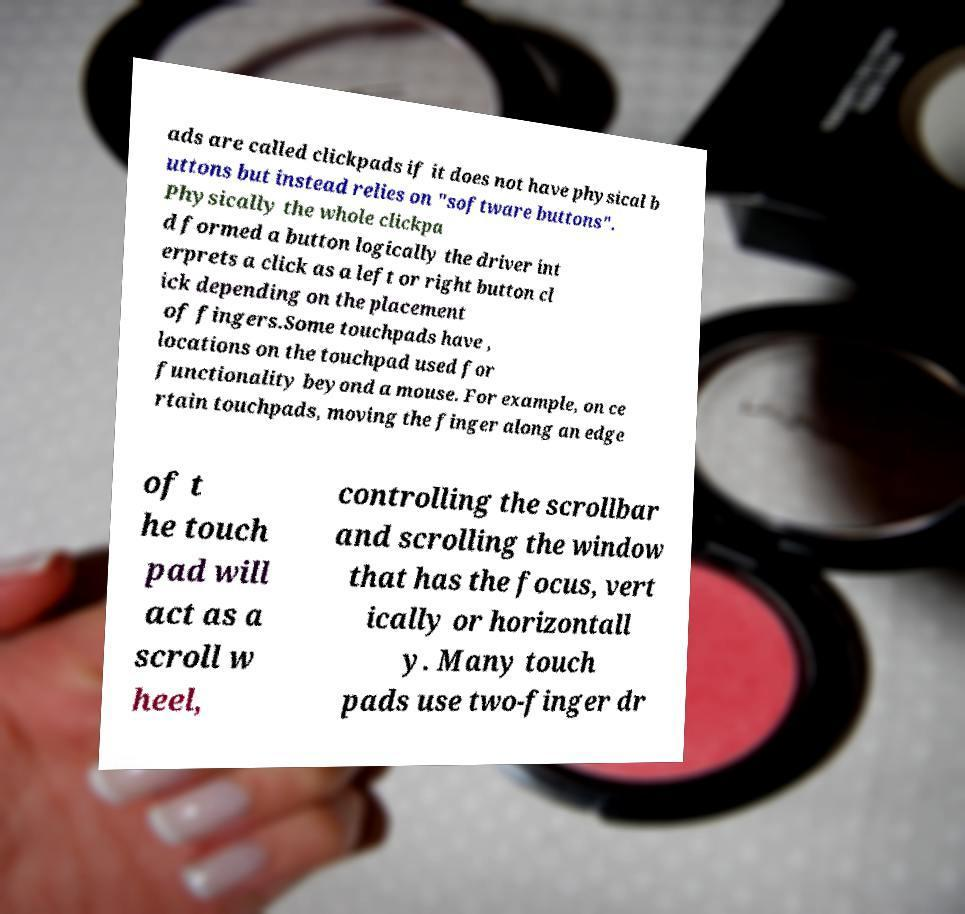Could you assist in decoding the text presented in this image and type it out clearly? ads are called clickpads if it does not have physical b uttons but instead relies on "software buttons". Physically the whole clickpa d formed a button logically the driver int erprets a click as a left or right button cl ick depending on the placement of fingers.Some touchpads have , locations on the touchpad used for functionality beyond a mouse. For example, on ce rtain touchpads, moving the finger along an edge of t he touch pad will act as a scroll w heel, controlling the scrollbar and scrolling the window that has the focus, vert ically or horizontall y. Many touch pads use two-finger dr 